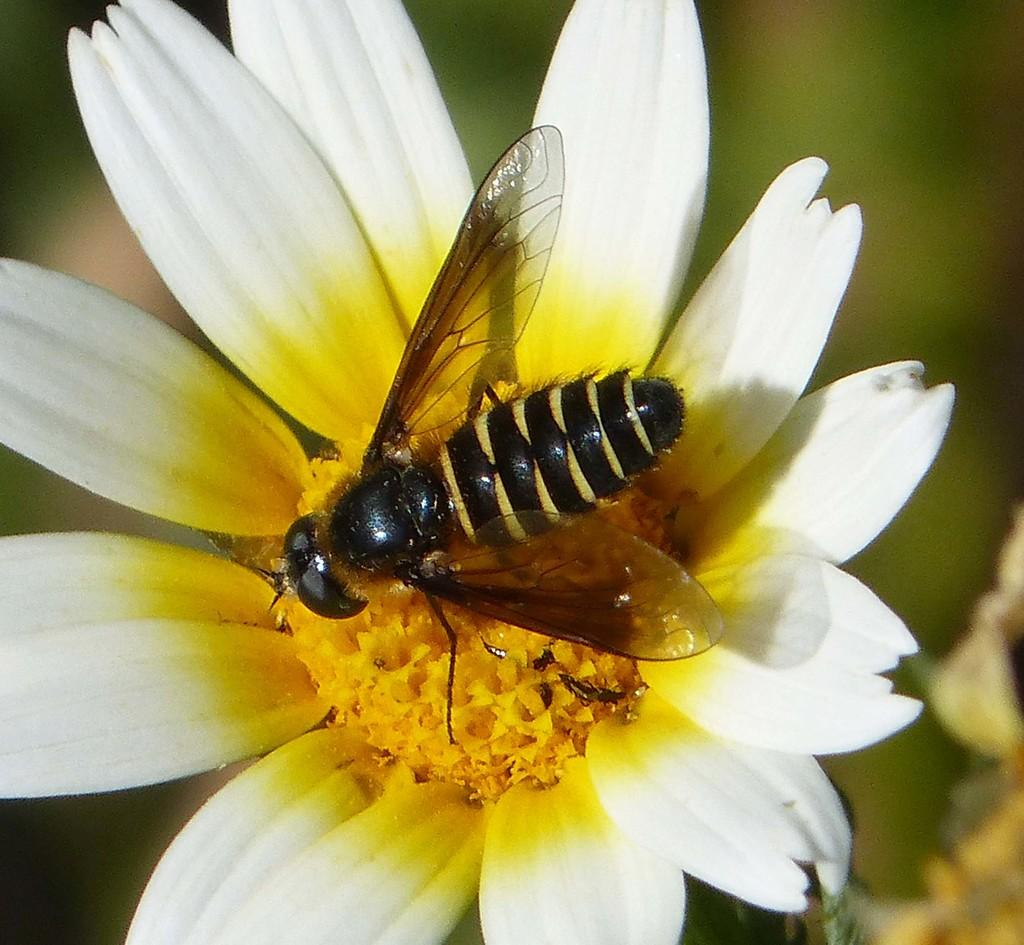What is the main subject of the image? There is a bee in the image. Where is the bee located in the image? The bee is sitting on a flower. Can you describe the background of the image? The background of the image is blurred. What type of property is visible in the background of the image? There is no property visible in the background of the image; it is blurred. Can you tell me how many people are visiting the cemetery in the image? There is no cemetery present in the image; it features a bee sitting on a flower. 